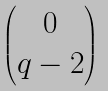<formula> <loc_0><loc_0><loc_500><loc_500>\begin{pmatrix} 0 \\ q - 2 \end{pmatrix}</formula> 